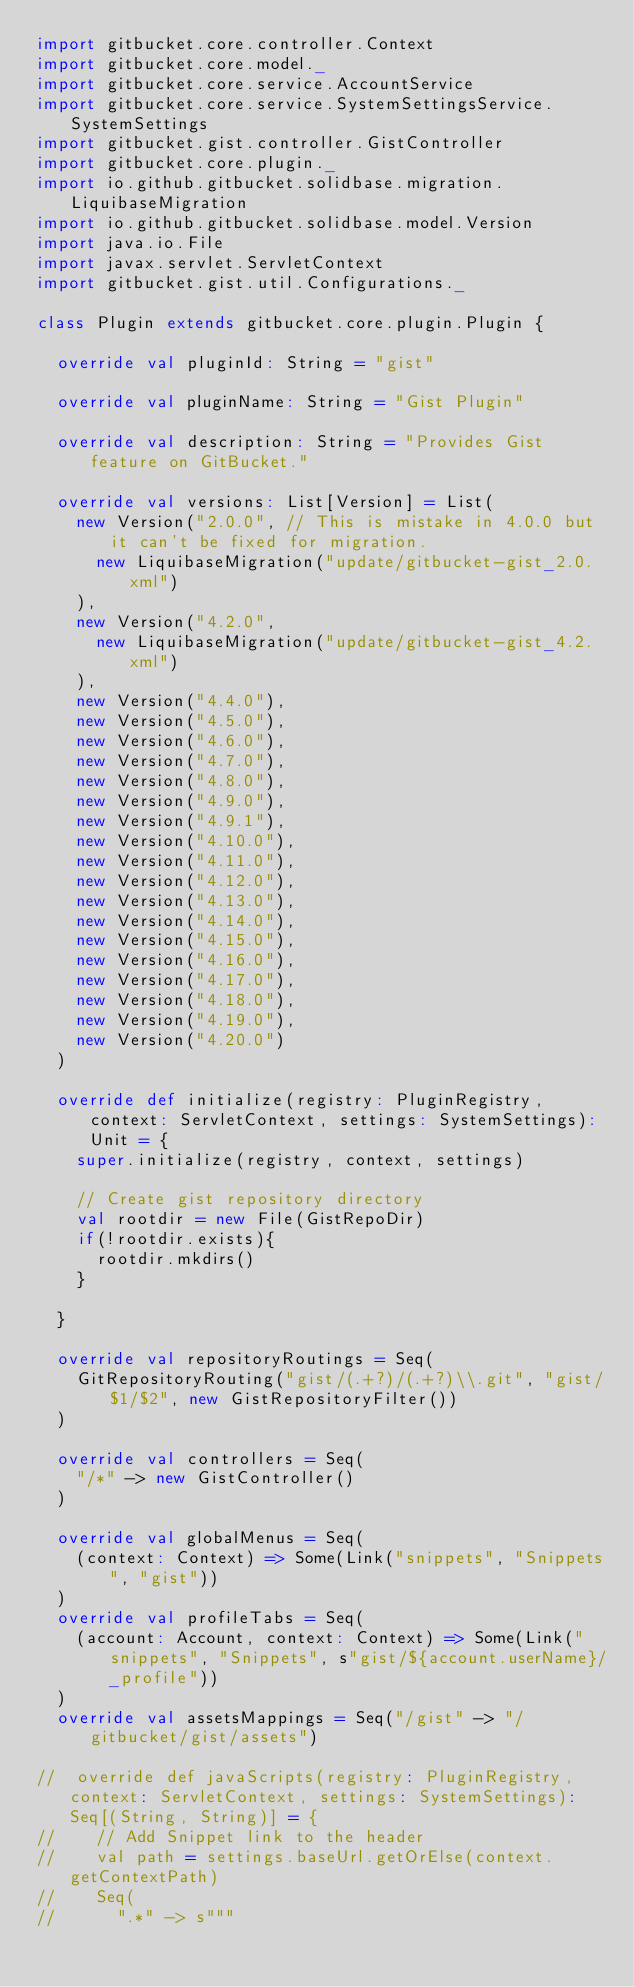<code> <loc_0><loc_0><loc_500><loc_500><_Scala_>import gitbucket.core.controller.Context
import gitbucket.core.model._
import gitbucket.core.service.AccountService
import gitbucket.core.service.SystemSettingsService.SystemSettings
import gitbucket.gist.controller.GistController
import gitbucket.core.plugin._
import io.github.gitbucket.solidbase.migration.LiquibaseMigration
import io.github.gitbucket.solidbase.model.Version
import java.io.File
import javax.servlet.ServletContext
import gitbucket.gist.util.Configurations._

class Plugin extends gitbucket.core.plugin.Plugin {

  override val pluginId: String = "gist"

  override val pluginName: String = "Gist Plugin"

  override val description: String = "Provides Gist feature on GitBucket."

  override val versions: List[Version] = List(
    new Version("2.0.0", // This is mistake in 4.0.0 but it can't be fixed for migration.
      new LiquibaseMigration("update/gitbucket-gist_2.0.xml")
    ),
    new Version("4.2.0",
      new LiquibaseMigration("update/gitbucket-gist_4.2.xml")
    ),
    new Version("4.4.0"),
    new Version("4.5.0"),
    new Version("4.6.0"),
    new Version("4.7.0"),
    new Version("4.8.0"),
    new Version("4.9.0"),
    new Version("4.9.1"),
    new Version("4.10.0"),
    new Version("4.11.0"),
    new Version("4.12.0"),
    new Version("4.13.0"),
    new Version("4.14.0"),
    new Version("4.15.0"),
    new Version("4.16.0"),
    new Version("4.17.0"),
    new Version("4.18.0"),
    new Version("4.19.0"),
    new Version("4.20.0")
  )

  override def initialize(registry: PluginRegistry, context: ServletContext, settings: SystemSettings): Unit = {
    super.initialize(registry, context, settings)

    // Create gist repository directory
    val rootdir = new File(GistRepoDir)
    if(!rootdir.exists){
      rootdir.mkdirs()
    }

  }

  override val repositoryRoutings = Seq(
    GitRepositoryRouting("gist/(.+?)/(.+?)\\.git", "gist/$1/$2", new GistRepositoryFilter())
  )

  override val controllers = Seq(
    "/*" -> new GistController()
  )

  override val globalMenus = Seq(
    (context: Context) => Some(Link("snippets", "Snippets", "gist"))
  )
  override val profileTabs = Seq(
    (account: Account, context: Context) => Some(Link("snippets", "Snippets", s"gist/${account.userName}/_profile"))
  )
  override val assetsMappings = Seq("/gist" -> "/gitbucket/gist/assets")

//  override def javaScripts(registry: PluginRegistry, context: ServletContext, settings: SystemSettings): Seq[(String, String)] = {
//    // Add Snippet link to the header
//    val path = settings.baseUrl.getOrElse(context.getContextPath)
//    Seq(
//      ".*" -> s"""</code> 